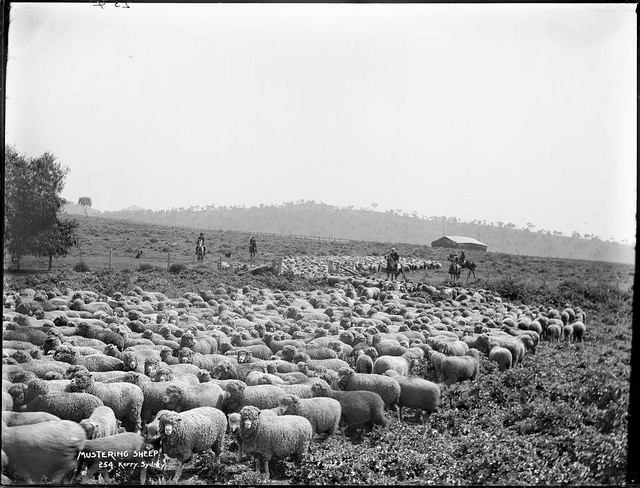Describe the objects in this image and their specific colors. I can see sheep in gray, darkgray, lightgray, and black tones, sheep in gray, black, darkgray, and lightgray tones, sheep in gray, black, darkgray, and lightgray tones, sheep in gray, black, darkgray, and lightgray tones, and sheep in gray, black, darkgray, and lightgray tones in this image. 